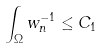<formula> <loc_0><loc_0><loc_500><loc_500>\int _ { \Omega } w _ { n } ^ { - 1 } \leq C _ { 1 }</formula> 